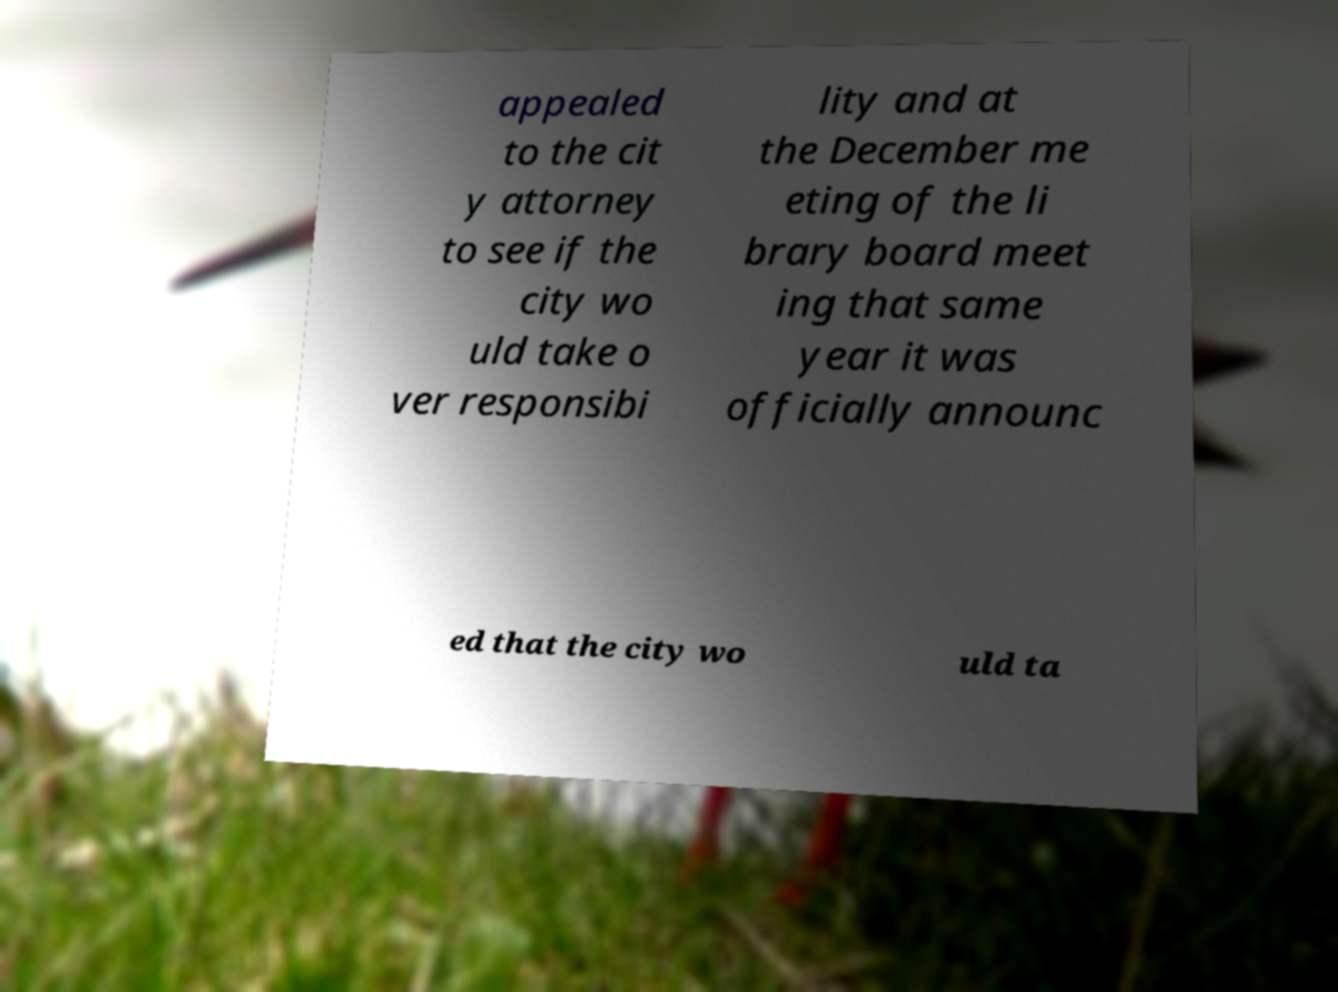Please identify and transcribe the text found in this image. appealed to the cit y attorney to see if the city wo uld take o ver responsibi lity and at the December me eting of the li brary board meet ing that same year it was officially announc ed that the city wo uld ta 